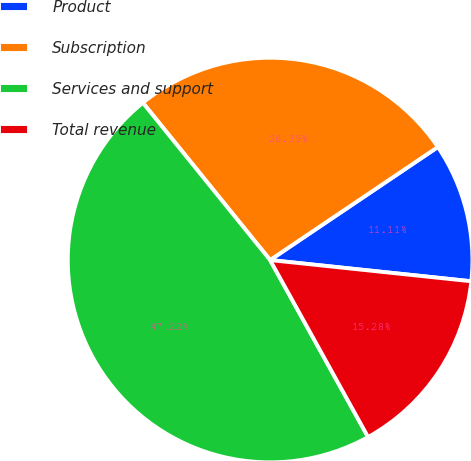Convert chart to OTSL. <chart><loc_0><loc_0><loc_500><loc_500><pie_chart><fcel>Product<fcel>Subscription<fcel>Services and support<fcel>Total revenue<nl><fcel>11.11%<fcel>26.39%<fcel>47.22%<fcel>15.28%<nl></chart> 